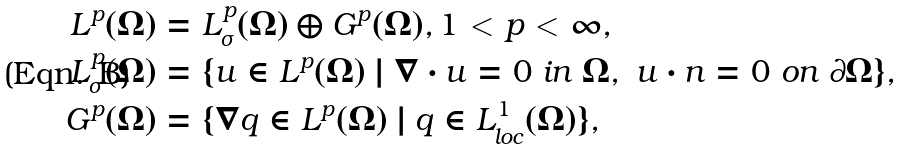Convert formula to latex. <formula><loc_0><loc_0><loc_500><loc_500>L ^ { p } ( \Omega ) & = L ^ { p } _ { \sigma } ( \Omega ) \oplus G ^ { p } ( \Omega ) , 1 < p < \infty , \\ L ^ { p } _ { \sigma } ( \Omega ) & = \{ u \in L ^ { p } ( \Omega ) \ | \ \nabla \cdot u = 0 \ i n \ \Omega , \ u \cdot n = 0 \ o n \ \partial \Omega \} , \\ G ^ { p } ( \Omega ) & = \{ \nabla q \in L ^ { p } ( \Omega ) \ | \ q \in L ^ { 1 } _ { l o c } ( \Omega ) \} ,</formula> 